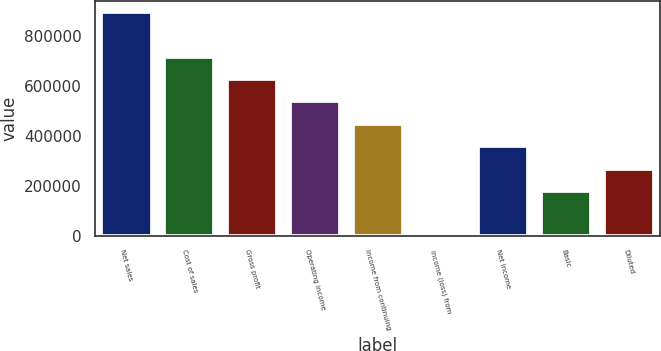Convert chart. <chart><loc_0><loc_0><loc_500><loc_500><bar_chart><fcel>Net sales<fcel>Cost of sales<fcel>Gross profit<fcel>Operating income<fcel>Income from continuing<fcel>Income (loss) from<fcel>Net income<fcel>Basic<fcel>Diluted<nl><fcel>894359<fcel>715487<fcel>626051<fcel>536615<fcel>447180<fcel>0.05<fcel>357744<fcel>178872<fcel>268308<nl></chart> 